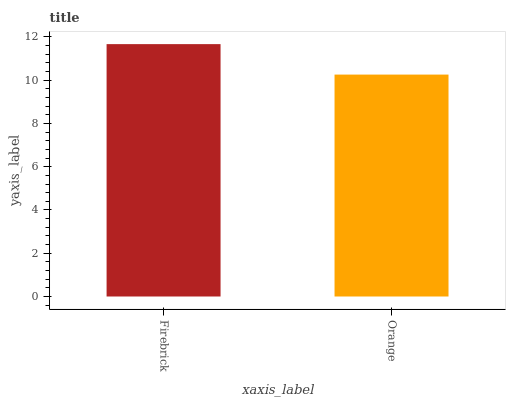Is Orange the maximum?
Answer yes or no. No. Is Firebrick greater than Orange?
Answer yes or no. Yes. Is Orange less than Firebrick?
Answer yes or no. Yes. Is Orange greater than Firebrick?
Answer yes or no. No. Is Firebrick less than Orange?
Answer yes or no. No. Is Firebrick the high median?
Answer yes or no. Yes. Is Orange the low median?
Answer yes or no. Yes. Is Orange the high median?
Answer yes or no. No. Is Firebrick the low median?
Answer yes or no. No. 